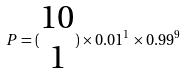<formula> <loc_0><loc_0><loc_500><loc_500>P = ( \begin{matrix} 1 0 \\ 1 \end{matrix} ) \times 0 . 0 1 ^ { 1 } \times 0 . 9 9 ^ { 9 }</formula> 